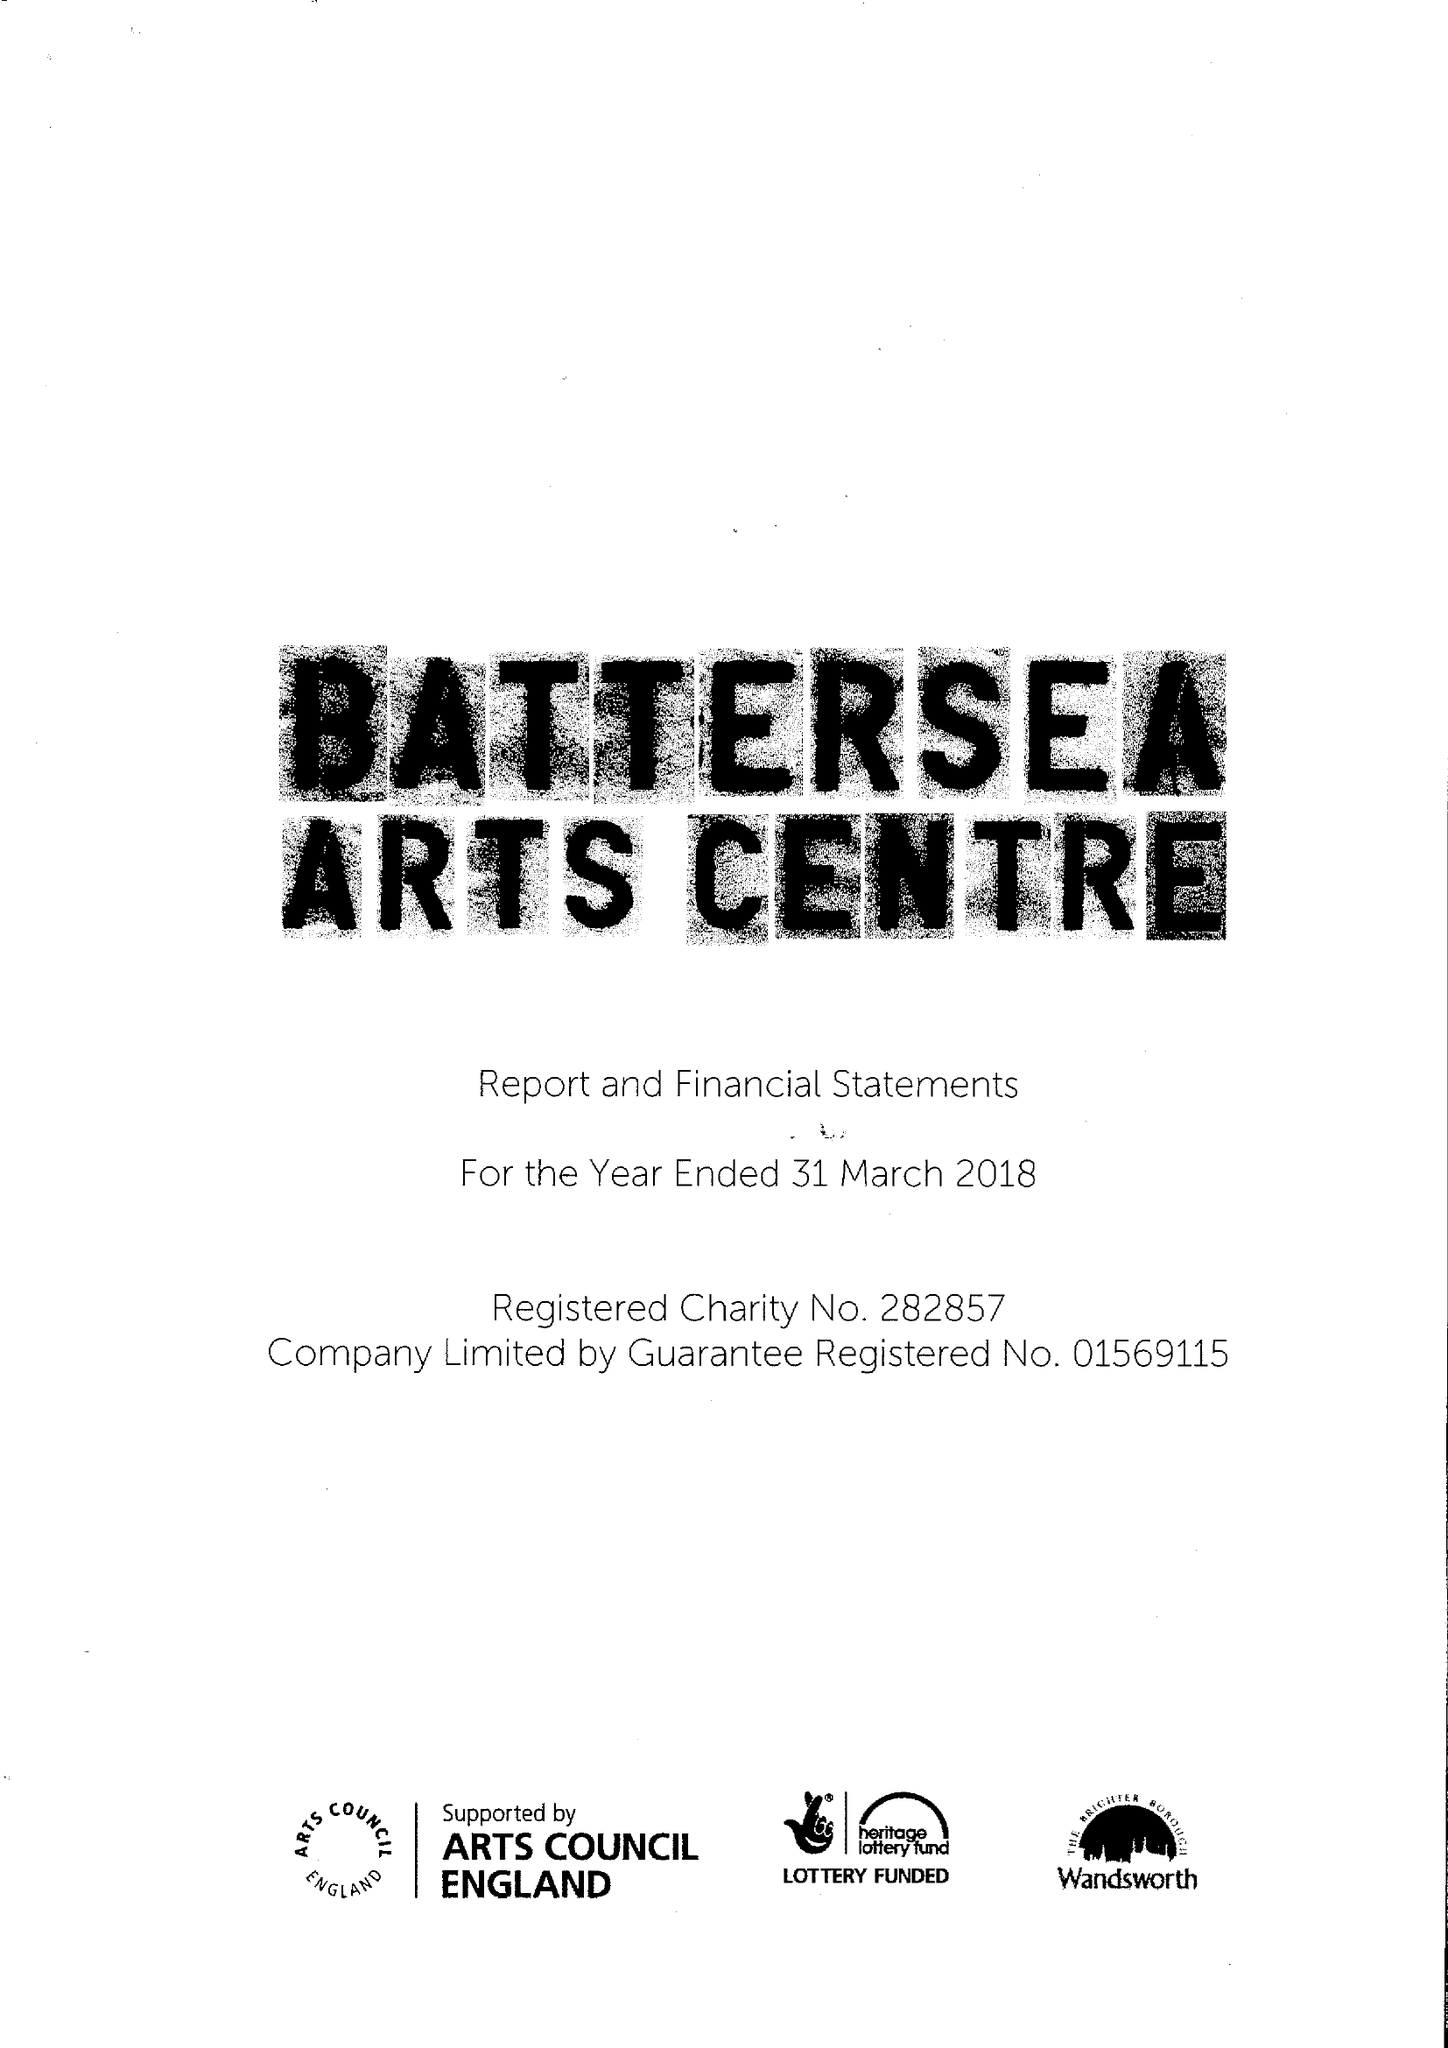What is the value for the spending_annually_in_british_pounds?
Answer the question using a single word or phrase. 4981581.00 